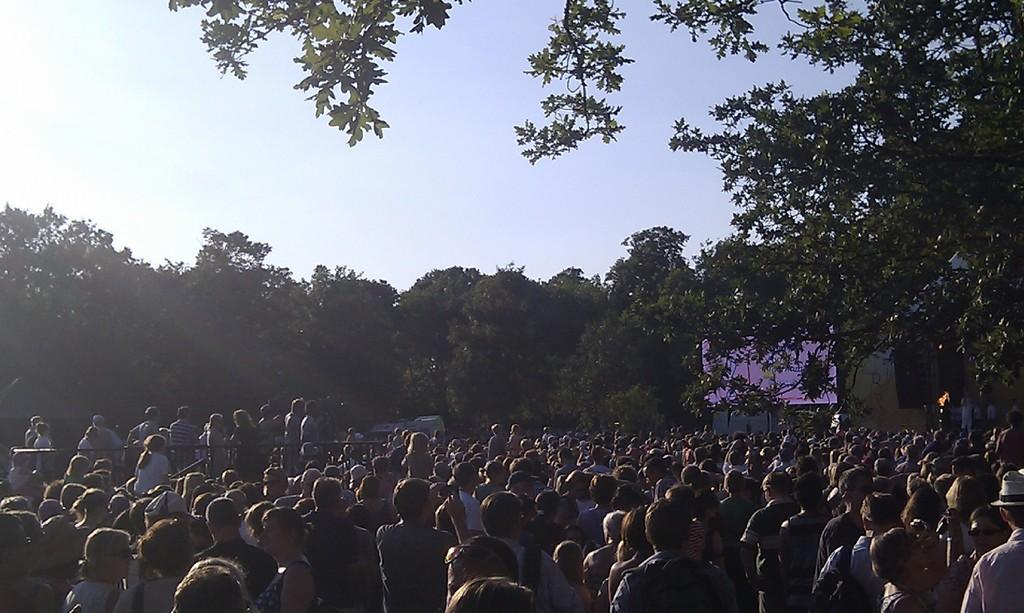Describe this image in one or two sentences. In this image I can see the group of people standing. I can see few trees, screen and fencing. The sky is in blue and white color. 